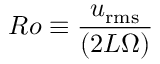Convert formula to latex. <formula><loc_0><loc_0><loc_500><loc_500>R o \equiv \frac { u _ { r m s } } { ( 2 L \Omega ) }</formula> 